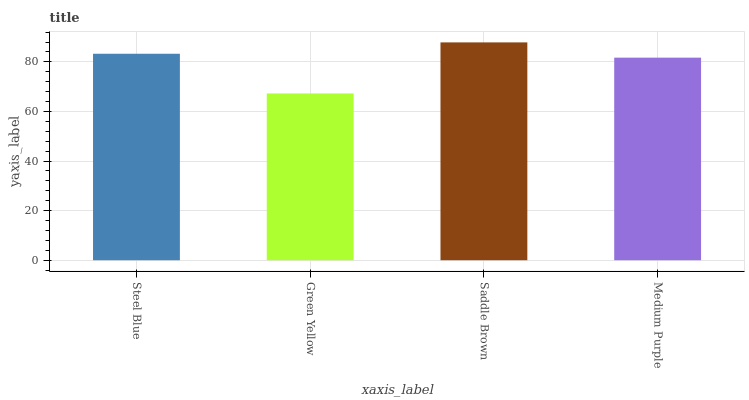Is Green Yellow the minimum?
Answer yes or no. Yes. Is Saddle Brown the maximum?
Answer yes or no. Yes. Is Saddle Brown the minimum?
Answer yes or no. No. Is Green Yellow the maximum?
Answer yes or no. No. Is Saddle Brown greater than Green Yellow?
Answer yes or no. Yes. Is Green Yellow less than Saddle Brown?
Answer yes or no. Yes. Is Green Yellow greater than Saddle Brown?
Answer yes or no. No. Is Saddle Brown less than Green Yellow?
Answer yes or no. No. Is Steel Blue the high median?
Answer yes or no. Yes. Is Medium Purple the low median?
Answer yes or no. Yes. Is Green Yellow the high median?
Answer yes or no. No. Is Green Yellow the low median?
Answer yes or no. No. 